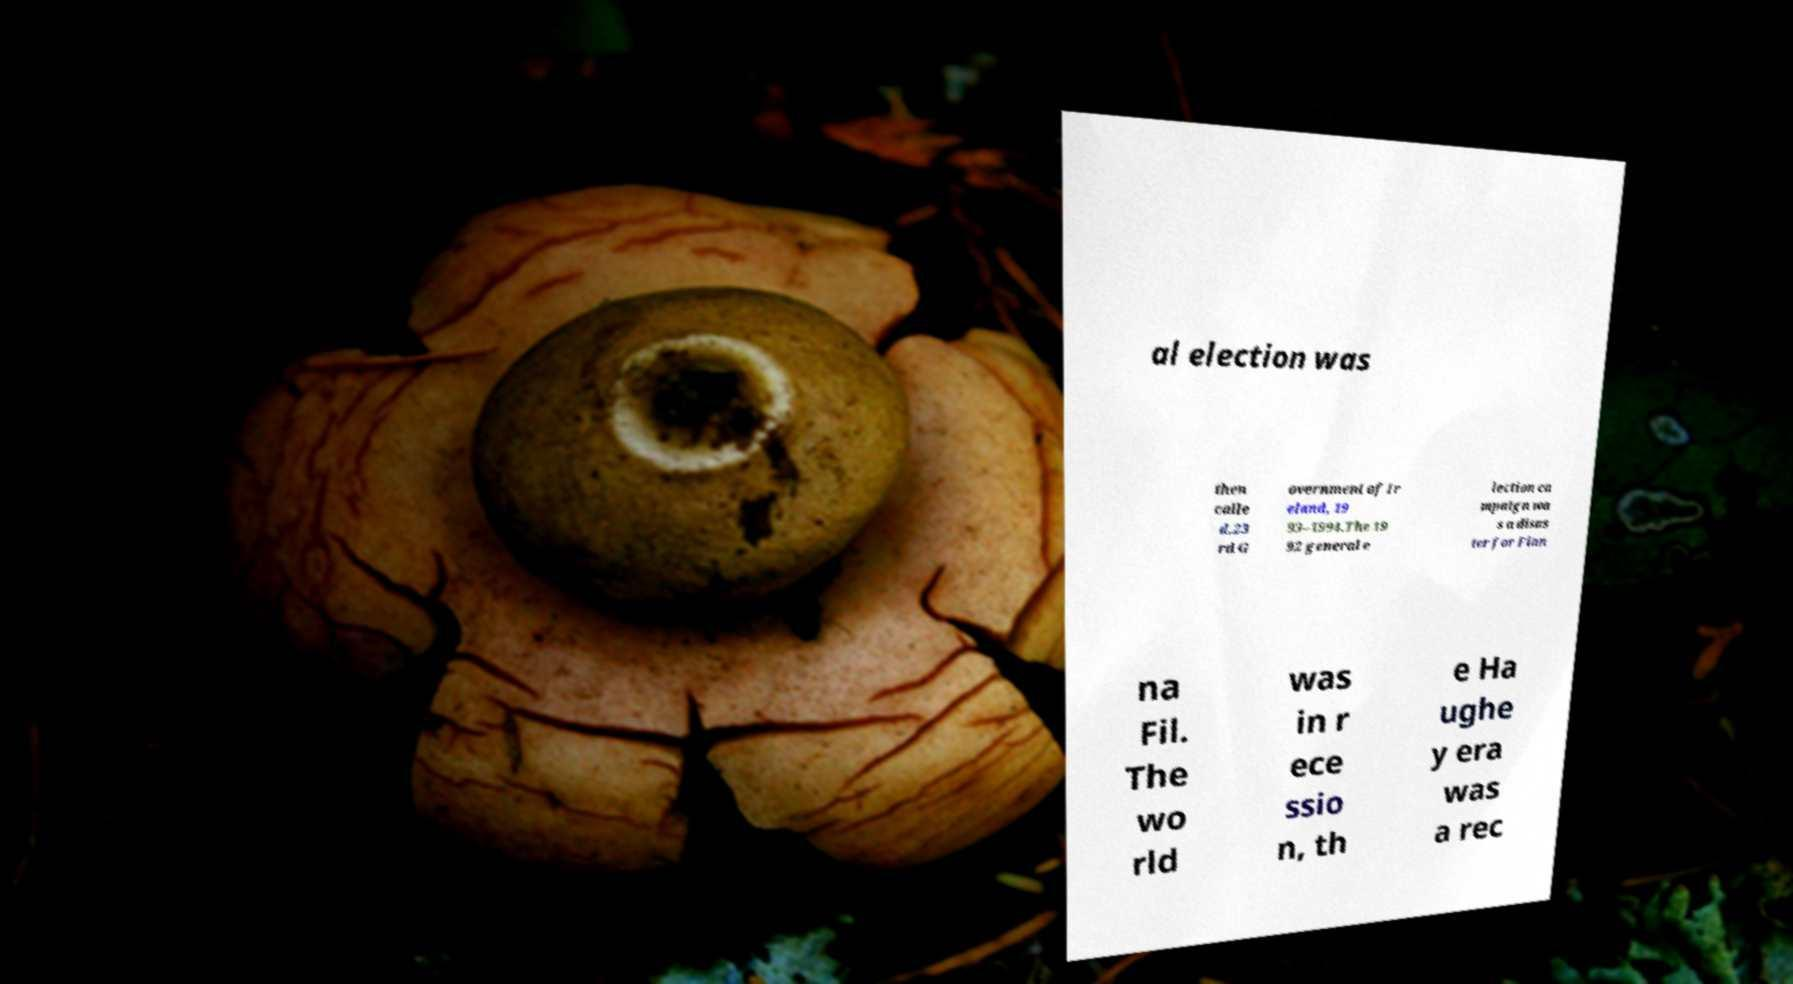Can you read and provide the text displayed in the image?This photo seems to have some interesting text. Can you extract and type it out for me? al election was then calle d.23 rd G overnment of Ir eland, 19 93–1994.The 19 92 general e lection ca mpaign wa s a disas ter for Fian na Fil. The wo rld was in r ece ssio n, th e Ha ughe y era was a rec 